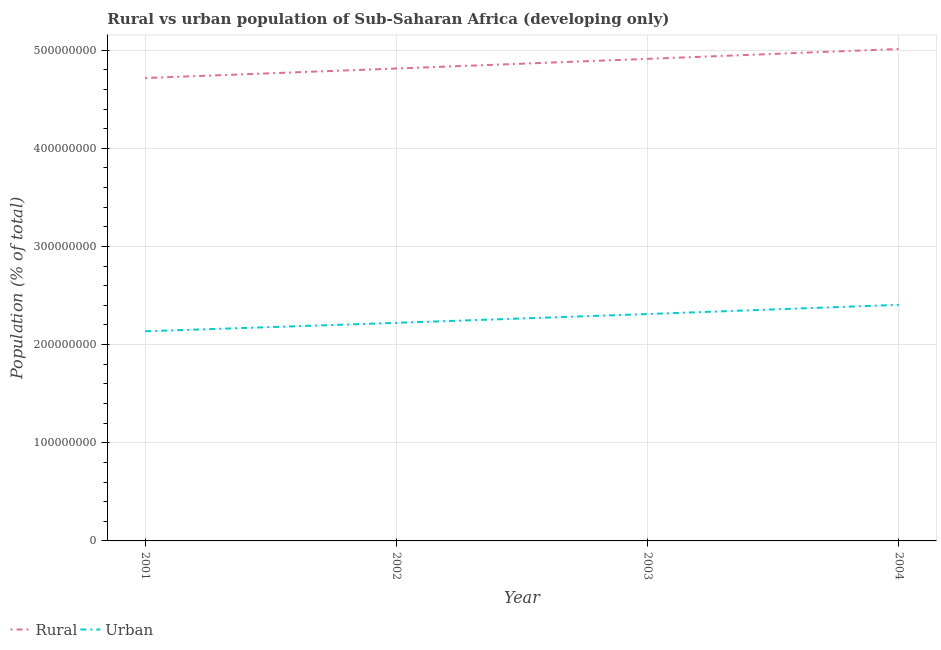How many different coloured lines are there?
Offer a very short reply. 2. What is the urban population density in 2002?
Provide a succinct answer. 2.22e+08. Across all years, what is the maximum rural population density?
Provide a short and direct response. 5.01e+08. Across all years, what is the minimum rural population density?
Ensure brevity in your answer.  4.72e+08. In which year was the urban population density maximum?
Make the answer very short. 2004. In which year was the rural population density minimum?
Offer a terse response. 2001. What is the total rural population density in the graph?
Keep it short and to the point. 1.95e+09. What is the difference between the urban population density in 2002 and that in 2003?
Your response must be concise. -8.97e+06. What is the difference between the rural population density in 2004 and the urban population density in 2002?
Offer a very short reply. 2.79e+08. What is the average urban population density per year?
Provide a short and direct response. 2.27e+08. In the year 2001, what is the difference between the rural population density and urban population density?
Ensure brevity in your answer.  2.58e+08. In how many years, is the urban population density greater than 200000000 %?
Offer a terse response. 4. What is the ratio of the urban population density in 2003 to that in 2004?
Make the answer very short. 0.96. Is the difference between the rural population density in 2001 and 2004 greater than the difference between the urban population density in 2001 and 2004?
Keep it short and to the point. No. What is the difference between the highest and the second highest rural population density?
Keep it short and to the point. 1.01e+07. What is the difference between the highest and the lowest rural population density?
Keep it short and to the point. 2.96e+07. In how many years, is the urban population density greater than the average urban population density taken over all years?
Provide a succinct answer. 2. How many years are there in the graph?
Ensure brevity in your answer.  4. Are the values on the major ticks of Y-axis written in scientific E-notation?
Ensure brevity in your answer.  No. Where does the legend appear in the graph?
Give a very brief answer. Bottom left. How many legend labels are there?
Your response must be concise. 2. How are the legend labels stacked?
Provide a succinct answer. Horizontal. What is the title of the graph?
Keep it short and to the point. Rural vs urban population of Sub-Saharan Africa (developing only). Does "ODA received" appear as one of the legend labels in the graph?
Your answer should be compact. No. What is the label or title of the X-axis?
Your response must be concise. Year. What is the label or title of the Y-axis?
Offer a very short reply. Population (% of total). What is the Population (% of total) in Rural in 2001?
Give a very brief answer. 4.72e+08. What is the Population (% of total) of Urban in 2001?
Provide a succinct answer. 2.14e+08. What is the Population (% of total) in Rural in 2002?
Ensure brevity in your answer.  4.81e+08. What is the Population (% of total) of Urban in 2002?
Give a very brief answer. 2.22e+08. What is the Population (% of total) of Rural in 2003?
Your answer should be compact. 4.91e+08. What is the Population (% of total) in Urban in 2003?
Your answer should be very brief. 2.31e+08. What is the Population (% of total) of Rural in 2004?
Your response must be concise. 5.01e+08. What is the Population (% of total) of Urban in 2004?
Provide a short and direct response. 2.41e+08. Across all years, what is the maximum Population (% of total) in Rural?
Keep it short and to the point. 5.01e+08. Across all years, what is the maximum Population (% of total) in Urban?
Offer a terse response. 2.41e+08. Across all years, what is the minimum Population (% of total) in Rural?
Offer a very short reply. 4.72e+08. Across all years, what is the minimum Population (% of total) of Urban?
Your answer should be compact. 2.14e+08. What is the total Population (% of total) in Rural in the graph?
Offer a terse response. 1.95e+09. What is the total Population (% of total) of Urban in the graph?
Make the answer very short. 9.07e+08. What is the difference between the Population (% of total) in Rural in 2001 and that in 2002?
Give a very brief answer. -9.68e+06. What is the difference between the Population (% of total) in Urban in 2001 and that in 2002?
Keep it short and to the point. -8.61e+06. What is the difference between the Population (% of total) of Rural in 2001 and that in 2003?
Your response must be concise. -1.95e+07. What is the difference between the Population (% of total) of Urban in 2001 and that in 2003?
Your answer should be very brief. -1.76e+07. What is the difference between the Population (% of total) of Rural in 2001 and that in 2004?
Your answer should be very brief. -2.96e+07. What is the difference between the Population (% of total) in Urban in 2001 and that in 2004?
Make the answer very short. -2.70e+07. What is the difference between the Population (% of total) of Rural in 2002 and that in 2003?
Offer a terse response. -9.83e+06. What is the difference between the Population (% of total) of Urban in 2002 and that in 2003?
Offer a very short reply. -8.97e+06. What is the difference between the Population (% of total) of Rural in 2002 and that in 2004?
Offer a terse response. -1.99e+07. What is the difference between the Population (% of total) in Urban in 2002 and that in 2004?
Give a very brief answer. -1.84e+07. What is the difference between the Population (% of total) of Rural in 2003 and that in 2004?
Your response must be concise. -1.01e+07. What is the difference between the Population (% of total) in Urban in 2003 and that in 2004?
Make the answer very short. -9.39e+06. What is the difference between the Population (% of total) of Rural in 2001 and the Population (% of total) of Urban in 2002?
Make the answer very short. 2.49e+08. What is the difference between the Population (% of total) in Rural in 2001 and the Population (% of total) in Urban in 2003?
Give a very brief answer. 2.40e+08. What is the difference between the Population (% of total) of Rural in 2001 and the Population (% of total) of Urban in 2004?
Offer a very short reply. 2.31e+08. What is the difference between the Population (% of total) in Rural in 2002 and the Population (% of total) in Urban in 2003?
Ensure brevity in your answer.  2.50e+08. What is the difference between the Population (% of total) in Rural in 2002 and the Population (% of total) in Urban in 2004?
Keep it short and to the point. 2.41e+08. What is the difference between the Population (% of total) in Rural in 2003 and the Population (% of total) in Urban in 2004?
Your response must be concise. 2.51e+08. What is the average Population (% of total) of Rural per year?
Your answer should be very brief. 4.86e+08. What is the average Population (% of total) of Urban per year?
Provide a short and direct response. 2.27e+08. In the year 2001, what is the difference between the Population (% of total) in Rural and Population (% of total) in Urban?
Provide a succinct answer. 2.58e+08. In the year 2002, what is the difference between the Population (% of total) in Rural and Population (% of total) in Urban?
Offer a terse response. 2.59e+08. In the year 2003, what is the difference between the Population (% of total) in Rural and Population (% of total) in Urban?
Your answer should be very brief. 2.60e+08. In the year 2004, what is the difference between the Population (% of total) in Rural and Population (% of total) in Urban?
Ensure brevity in your answer.  2.61e+08. What is the ratio of the Population (% of total) of Rural in 2001 to that in 2002?
Give a very brief answer. 0.98. What is the ratio of the Population (% of total) of Urban in 2001 to that in 2002?
Provide a succinct answer. 0.96. What is the ratio of the Population (% of total) of Rural in 2001 to that in 2003?
Keep it short and to the point. 0.96. What is the ratio of the Population (% of total) of Urban in 2001 to that in 2003?
Your response must be concise. 0.92. What is the ratio of the Population (% of total) in Rural in 2001 to that in 2004?
Provide a short and direct response. 0.94. What is the ratio of the Population (% of total) of Urban in 2001 to that in 2004?
Provide a succinct answer. 0.89. What is the ratio of the Population (% of total) in Rural in 2002 to that in 2003?
Provide a succinct answer. 0.98. What is the ratio of the Population (% of total) of Urban in 2002 to that in 2003?
Keep it short and to the point. 0.96. What is the ratio of the Population (% of total) of Rural in 2002 to that in 2004?
Provide a succinct answer. 0.96. What is the ratio of the Population (% of total) in Urban in 2002 to that in 2004?
Give a very brief answer. 0.92. What is the ratio of the Population (% of total) in Rural in 2003 to that in 2004?
Your answer should be compact. 0.98. What is the ratio of the Population (% of total) in Urban in 2003 to that in 2004?
Ensure brevity in your answer.  0.96. What is the difference between the highest and the second highest Population (% of total) of Rural?
Ensure brevity in your answer.  1.01e+07. What is the difference between the highest and the second highest Population (% of total) in Urban?
Your answer should be very brief. 9.39e+06. What is the difference between the highest and the lowest Population (% of total) of Rural?
Keep it short and to the point. 2.96e+07. What is the difference between the highest and the lowest Population (% of total) of Urban?
Provide a succinct answer. 2.70e+07. 